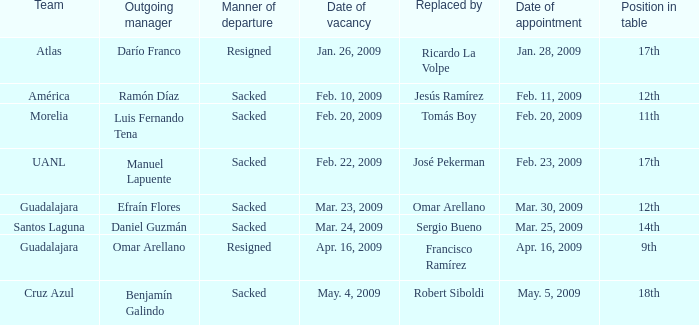What is Position in Table, when Replaced by is "José Pekerman"? 17th. 